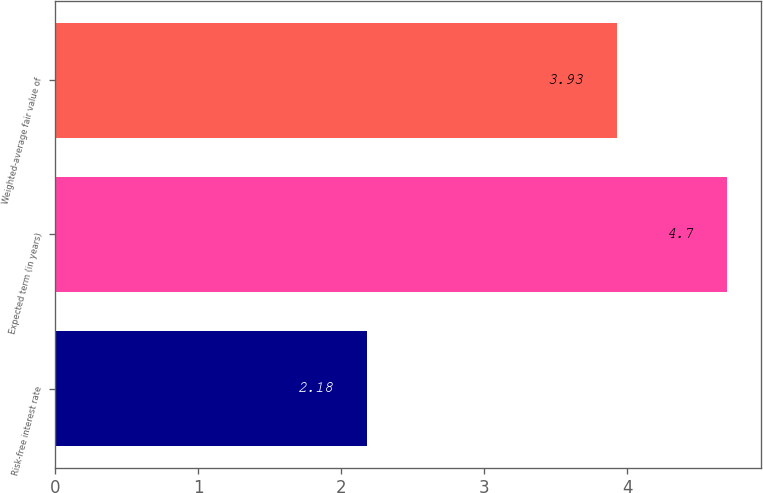Convert chart. <chart><loc_0><loc_0><loc_500><loc_500><bar_chart><fcel>Risk-free interest rate<fcel>Expected term (in years)<fcel>Weighted-average fair value of<nl><fcel>2.18<fcel>4.7<fcel>3.93<nl></chart> 